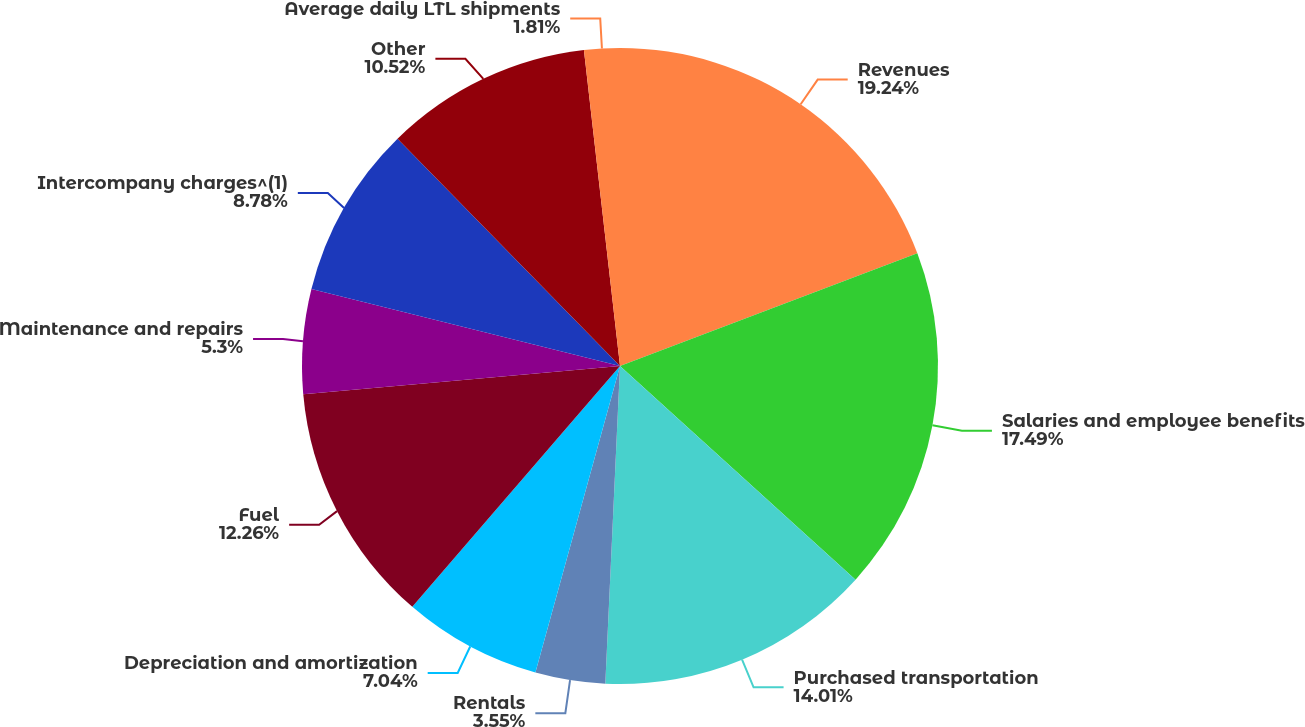Convert chart. <chart><loc_0><loc_0><loc_500><loc_500><pie_chart><fcel>Revenues<fcel>Salaries and employee benefits<fcel>Purchased transportation<fcel>Rentals<fcel>Depreciation and amortization<fcel>Fuel<fcel>Maintenance and repairs<fcel>Intercompany charges^(1)<fcel>Other<fcel>Average daily LTL shipments<nl><fcel>19.23%<fcel>17.49%<fcel>14.01%<fcel>3.55%<fcel>7.04%<fcel>12.26%<fcel>5.3%<fcel>8.78%<fcel>10.52%<fcel>1.81%<nl></chart> 